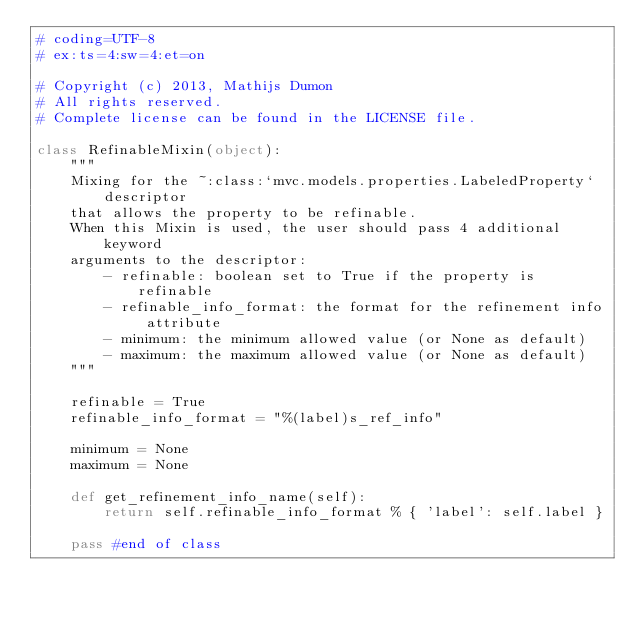<code> <loc_0><loc_0><loc_500><loc_500><_Python_># coding=UTF-8
# ex:ts=4:sw=4:et=on

# Copyright (c) 2013, Mathijs Dumon
# All rights reserved.
# Complete license can be found in the LICENSE file.

class RefinableMixin(object):
    """
    Mixing for the ~:class:`mvc.models.properties.LabeledProperty` descriptor
    that allows the property to be refinable.
    When this Mixin is used, the user should pass 4 additional keyword 
    arguments to the descriptor:
        - refinable: boolean set to True if the property is refinable
        - refinable_info_format: the format for the refinement info attribute
        - minimum: the minimum allowed value (or None as default)
        - maximum: the maximum allowed value (or None as default) 
    """

    refinable = True
    refinable_info_format = "%(label)s_ref_info"

    minimum = None
    maximum = None

    def get_refinement_info_name(self):
        return self.refinable_info_format % { 'label': self.label }

    pass #end of class</code> 